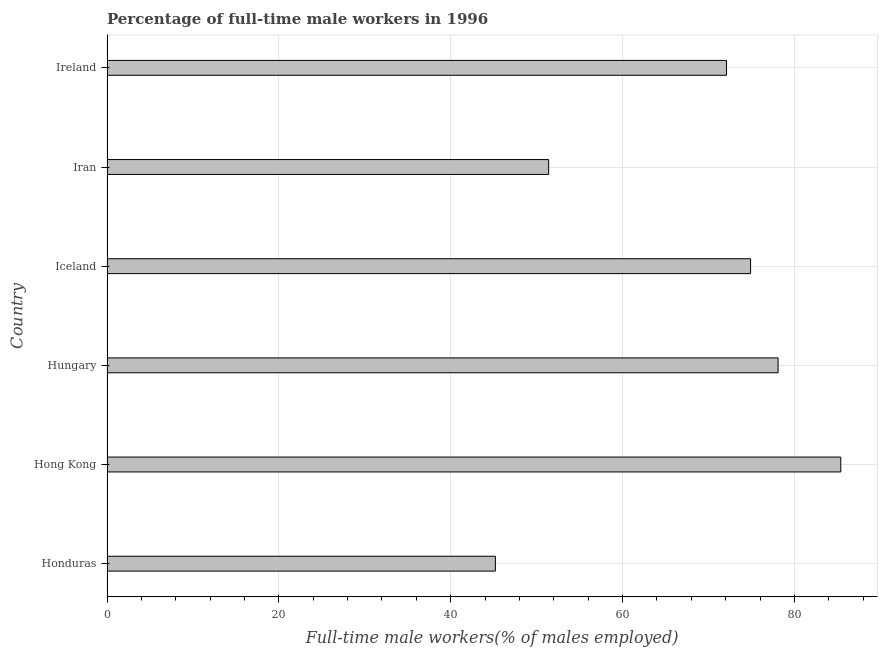Does the graph contain any zero values?
Your answer should be compact. No. What is the title of the graph?
Your response must be concise. Percentage of full-time male workers in 1996. What is the label or title of the X-axis?
Provide a short and direct response. Full-time male workers(% of males employed). What is the percentage of full-time male workers in Ireland?
Provide a succinct answer. 72.1. Across all countries, what is the maximum percentage of full-time male workers?
Your answer should be very brief. 85.4. Across all countries, what is the minimum percentage of full-time male workers?
Offer a terse response. 45.2. In which country was the percentage of full-time male workers maximum?
Give a very brief answer. Hong Kong. In which country was the percentage of full-time male workers minimum?
Keep it short and to the point. Honduras. What is the sum of the percentage of full-time male workers?
Keep it short and to the point. 407.1. What is the average percentage of full-time male workers per country?
Provide a succinct answer. 67.85. What is the median percentage of full-time male workers?
Your answer should be very brief. 73.5. What is the ratio of the percentage of full-time male workers in Iceland to that in Iran?
Keep it short and to the point. 1.46. Is the percentage of full-time male workers in Hungary less than that in Iran?
Offer a terse response. No. Is the difference between the percentage of full-time male workers in Hungary and Iran greater than the difference between any two countries?
Offer a terse response. No. What is the difference between the highest and the second highest percentage of full-time male workers?
Your answer should be compact. 7.3. Is the sum of the percentage of full-time male workers in Honduras and Ireland greater than the maximum percentage of full-time male workers across all countries?
Ensure brevity in your answer.  Yes. What is the difference between the highest and the lowest percentage of full-time male workers?
Your answer should be compact. 40.2. Are all the bars in the graph horizontal?
Make the answer very short. Yes. How many countries are there in the graph?
Your answer should be very brief. 6. Are the values on the major ticks of X-axis written in scientific E-notation?
Provide a short and direct response. No. What is the Full-time male workers(% of males employed) of Honduras?
Provide a succinct answer. 45.2. What is the Full-time male workers(% of males employed) in Hong Kong?
Offer a terse response. 85.4. What is the Full-time male workers(% of males employed) of Hungary?
Keep it short and to the point. 78.1. What is the Full-time male workers(% of males employed) of Iceland?
Your response must be concise. 74.9. What is the Full-time male workers(% of males employed) of Iran?
Provide a short and direct response. 51.4. What is the Full-time male workers(% of males employed) in Ireland?
Provide a short and direct response. 72.1. What is the difference between the Full-time male workers(% of males employed) in Honduras and Hong Kong?
Give a very brief answer. -40.2. What is the difference between the Full-time male workers(% of males employed) in Honduras and Hungary?
Your answer should be very brief. -32.9. What is the difference between the Full-time male workers(% of males employed) in Honduras and Iceland?
Offer a terse response. -29.7. What is the difference between the Full-time male workers(% of males employed) in Honduras and Iran?
Your response must be concise. -6.2. What is the difference between the Full-time male workers(% of males employed) in Honduras and Ireland?
Provide a short and direct response. -26.9. What is the difference between the Full-time male workers(% of males employed) in Hong Kong and Hungary?
Offer a very short reply. 7.3. What is the difference between the Full-time male workers(% of males employed) in Hong Kong and Iceland?
Your answer should be compact. 10.5. What is the difference between the Full-time male workers(% of males employed) in Hong Kong and Iran?
Offer a terse response. 34. What is the difference between the Full-time male workers(% of males employed) in Hong Kong and Ireland?
Provide a short and direct response. 13.3. What is the difference between the Full-time male workers(% of males employed) in Hungary and Iceland?
Keep it short and to the point. 3.2. What is the difference between the Full-time male workers(% of males employed) in Hungary and Iran?
Provide a short and direct response. 26.7. What is the difference between the Full-time male workers(% of males employed) in Hungary and Ireland?
Offer a terse response. 6. What is the difference between the Full-time male workers(% of males employed) in Iceland and Ireland?
Your answer should be compact. 2.8. What is the difference between the Full-time male workers(% of males employed) in Iran and Ireland?
Make the answer very short. -20.7. What is the ratio of the Full-time male workers(% of males employed) in Honduras to that in Hong Kong?
Offer a terse response. 0.53. What is the ratio of the Full-time male workers(% of males employed) in Honduras to that in Hungary?
Offer a very short reply. 0.58. What is the ratio of the Full-time male workers(% of males employed) in Honduras to that in Iceland?
Make the answer very short. 0.6. What is the ratio of the Full-time male workers(% of males employed) in Honduras to that in Iran?
Offer a very short reply. 0.88. What is the ratio of the Full-time male workers(% of males employed) in Honduras to that in Ireland?
Make the answer very short. 0.63. What is the ratio of the Full-time male workers(% of males employed) in Hong Kong to that in Hungary?
Make the answer very short. 1.09. What is the ratio of the Full-time male workers(% of males employed) in Hong Kong to that in Iceland?
Offer a very short reply. 1.14. What is the ratio of the Full-time male workers(% of males employed) in Hong Kong to that in Iran?
Give a very brief answer. 1.66. What is the ratio of the Full-time male workers(% of males employed) in Hong Kong to that in Ireland?
Your answer should be very brief. 1.18. What is the ratio of the Full-time male workers(% of males employed) in Hungary to that in Iceland?
Offer a terse response. 1.04. What is the ratio of the Full-time male workers(% of males employed) in Hungary to that in Iran?
Keep it short and to the point. 1.52. What is the ratio of the Full-time male workers(% of males employed) in Hungary to that in Ireland?
Offer a terse response. 1.08. What is the ratio of the Full-time male workers(% of males employed) in Iceland to that in Iran?
Ensure brevity in your answer.  1.46. What is the ratio of the Full-time male workers(% of males employed) in Iceland to that in Ireland?
Provide a succinct answer. 1.04. What is the ratio of the Full-time male workers(% of males employed) in Iran to that in Ireland?
Give a very brief answer. 0.71. 